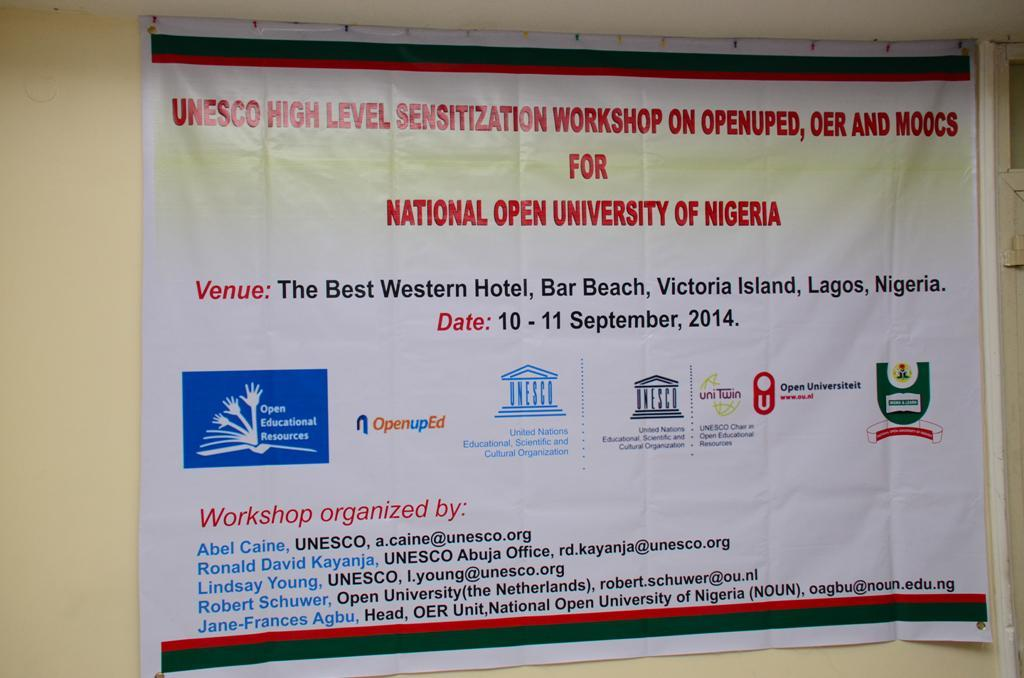<image>
Offer a succinct explanation of the picture presented. The banner is advertising a workshop for the Nation Open University of Nigeria. 